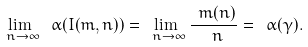Convert formula to latex. <formula><loc_0><loc_0><loc_500><loc_500>\lim _ { \ n \rightarrow \infty } { \ \alpha ( I ( m , n ) ) } = \lim _ { \ n \rightarrow \infty } \frac { \ m ( n ) } { \ n } = { \ \alpha ( \gamma ) . \ }</formula> 